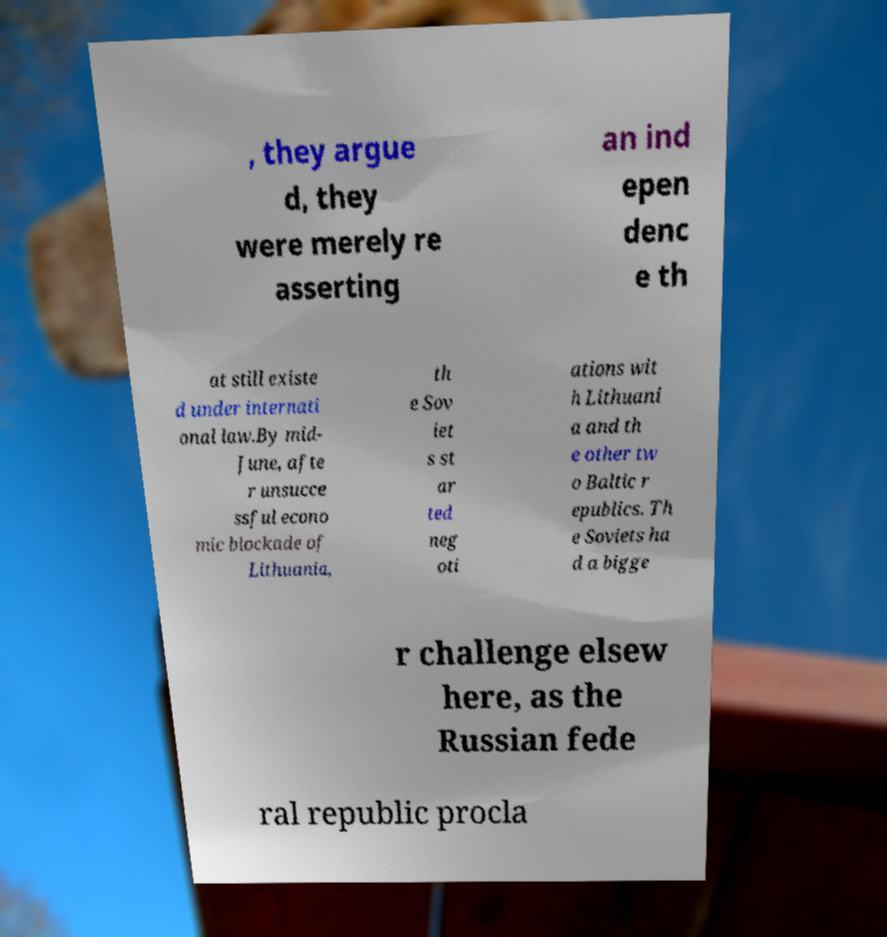Can you accurately transcribe the text from the provided image for me? , they argue d, they were merely re asserting an ind epen denc e th at still existe d under internati onal law.By mid- June, afte r unsucce ssful econo mic blockade of Lithuania, th e Sov iet s st ar ted neg oti ations wit h Lithuani a and th e other tw o Baltic r epublics. Th e Soviets ha d a bigge r challenge elsew here, as the Russian fede ral republic procla 